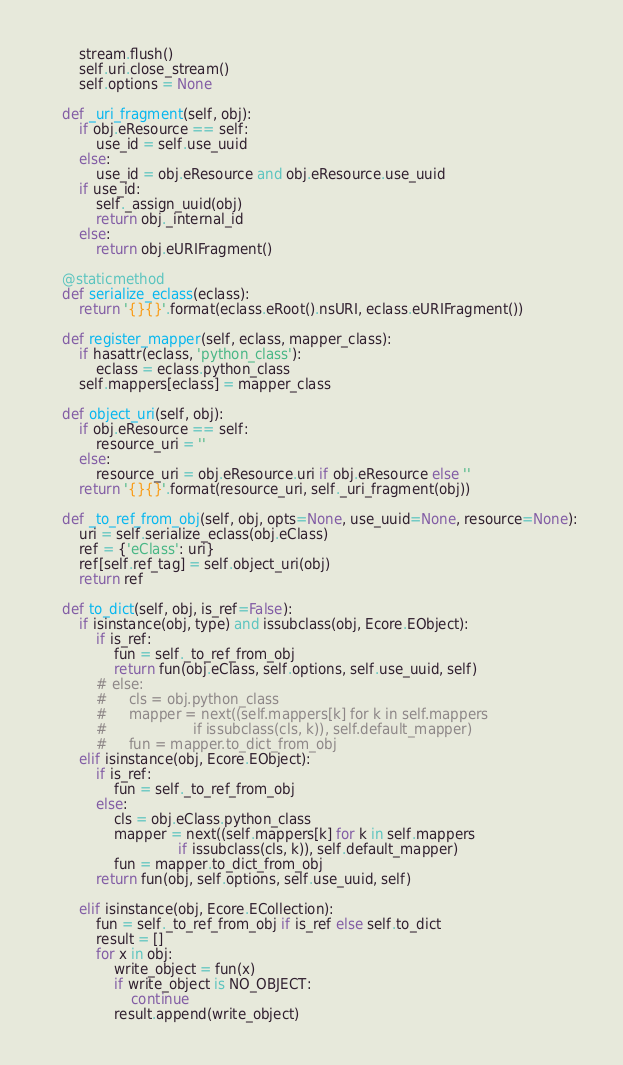Convert code to text. <code><loc_0><loc_0><loc_500><loc_500><_Python_>        stream.flush()
        self.uri.close_stream()
        self.options = None

    def _uri_fragment(self, obj):
        if obj.eResource == self:
            use_id = self.use_uuid
        else:
            use_id = obj.eResource and obj.eResource.use_uuid
        if use_id:
            self._assign_uuid(obj)
            return obj._internal_id
        else:
            return obj.eURIFragment()

    @staticmethod
    def serialize_eclass(eclass):
        return '{}{}'.format(eclass.eRoot().nsURI, eclass.eURIFragment())

    def register_mapper(self, eclass, mapper_class):
        if hasattr(eclass, 'python_class'):
            eclass = eclass.python_class
        self.mappers[eclass] = mapper_class

    def object_uri(self, obj):
        if obj.eResource == self:
            resource_uri = ''
        else:
            resource_uri = obj.eResource.uri if obj.eResource else ''
        return '{}{}'.format(resource_uri, self._uri_fragment(obj))

    def _to_ref_from_obj(self, obj, opts=None, use_uuid=None, resource=None):
        uri = self.serialize_eclass(obj.eClass)
        ref = {'eClass': uri}
        ref[self.ref_tag] = self.object_uri(obj)
        return ref

    def to_dict(self, obj, is_ref=False):
        if isinstance(obj, type) and issubclass(obj, Ecore.EObject):
            if is_ref:
                fun = self._to_ref_from_obj
                return fun(obj.eClass, self.options, self.use_uuid, self)
            # else:
            #     cls = obj.python_class
            #     mapper = next((self.mappers[k] for k in self.mappers
            #                    if issubclass(cls, k)), self.default_mapper)
            #     fun = mapper.to_dict_from_obj
        elif isinstance(obj, Ecore.EObject):
            if is_ref:
                fun = self._to_ref_from_obj
            else:
                cls = obj.eClass.python_class
                mapper = next((self.mappers[k] for k in self.mappers
                               if issubclass(cls, k)), self.default_mapper)
                fun = mapper.to_dict_from_obj
            return fun(obj, self.options, self.use_uuid, self)

        elif isinstance(obj, Ecore.ECollection):
            fun = self._to_ref_from_obj if is_ref else self.to_dict
            result = []
            for x in obj:
                write_object = fun(x)
                if write_object is NO_OBJECT:
                    continue
                result.append(write_object)</code> 